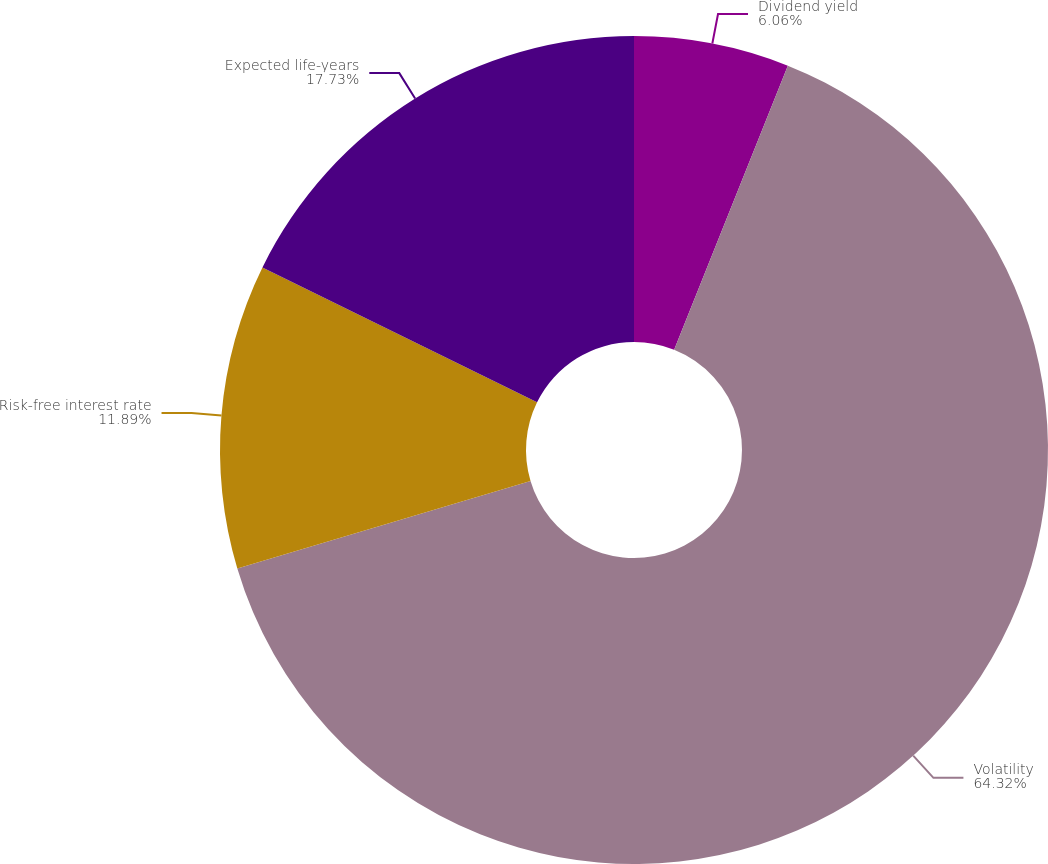Convert chart. <chart><loc_0><loc_0><loc_500><loc_500><pie_chart><fcel>Dividend yield<fcel>Volatility<fcel>Risk-free interest rate<fcel>Expected life-years<nl><fcel>6.06%<fcel>64.32%<fcel>11.89%<fcel>17.73%<nl></chart> 